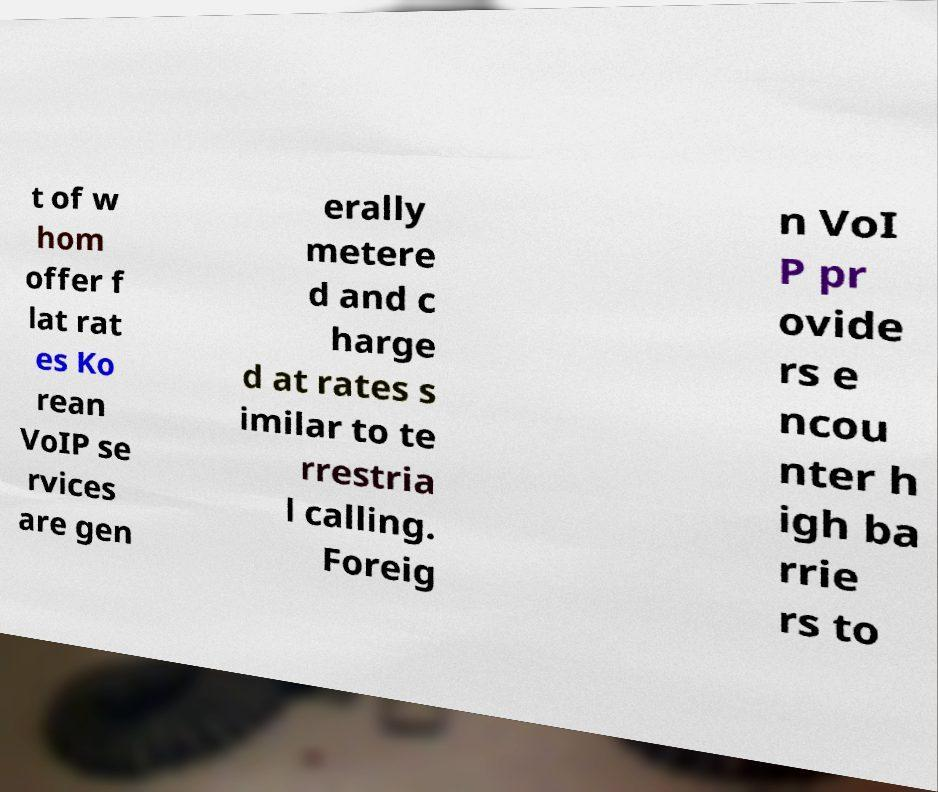There's text embedded in this image that I need extracted. Can you transcribe it verbatim? t of w hom offer f lat rat es Ko rean VoIP se rvices are gen erally metere d and c harge d at rates s imilar to te rrestria l calling. Foreig n VoI P pr ovide rs e ncou nter h igh ba rrie rs to 